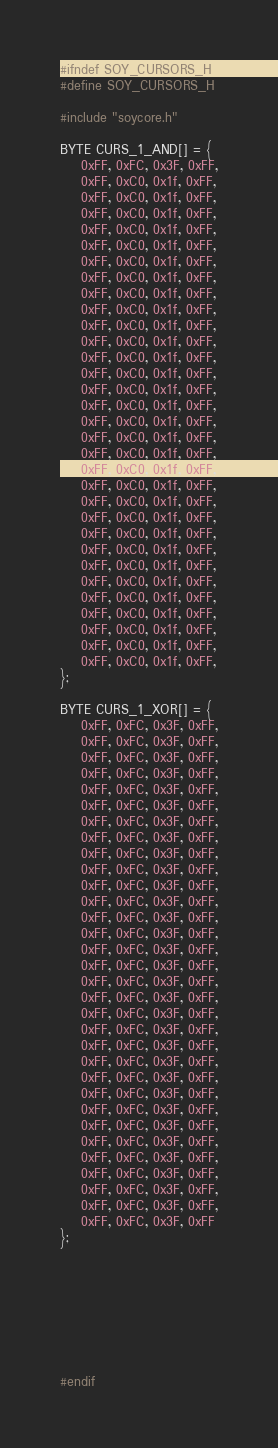<code> <loc_0><loc_0><loc_500><loc_500><_C_>#ifndef SOY_CURSORS_H
#define SOY_CURSORS_H

#include "soycore.h"

BYTE CURS_1_AND[] = {
	0xFF, 0xFC, 0x3F, 0xFF,
	0xFF, 0xC0, 0x1f, 0xFF,
	0xFF, 0xC0, 0x1f, 0xFF,
	0xFF, 0xC0, 0x1f, 0xFF,
	0xFF, 0xC0, 0x1f, 0xFF,
	0xFF, 0xC0, 0x1f, 0xFF,
	0xFF, 0xC0, 0x1f, 0xFF,
	0xFF, 0xC0, 0x1f, 0xFF,
	0xFF, 0xC0, 0x1f, 0xFF,
	0xFF, 0xC0, 0x1f, 0xFF,
	0xFF, 0xC0, 0x1f, 0xFF,
	0xFF, 0xC0, 0x1f, 0xFF,
	0xFF, 0xC0, 0x1f, 0xFF,
	0xFF, 0xC0, 0x1f, 0xFF,
	0xFF, 0xC0, 0x1f, 0xFF,
	0xFF, 0xC0, 0x1f, 0xFF,
	0xFF, 0xC0, 0x1f, 0xFF,
	0xFF, 0xC0, 0x1f, 0xFF,
	0xFF, 0xC0, 0x1f, 0xFF,
	0xFF, 0xC0, 0x1f, 0xFF,
	0xFF, 0xC0, 0x1f, 0xFF,
	0xFF, 0xC0, 0x1f, 0xFF,
	0xFF, 0xC0, 0x1f, 0xFF,
	0xFF, 0xC0, 0x1f, 0xFF,
	0xFF, 0xC0, 0x1f, 0xFF,
	0xFF, 0xC0, 0x1f, 0xFF,
	0xFF, 0xC0, 0x1f, 0xFF,
	0xFF, 0xC0, 0x1f, 0xFF,
	0xFF, 0xC0, 0x1f, 0xFF,
	0xFF, 0xC0, 0x1f, 0xFF,
	0xFF, 0xC0, 0x1f, 0xFF,
	0xFF, 0xC0, 0x1f, 0xFF,
};

BYTE CURS_1_XOR[] = {
	0xFF, 0xFC, 0x3F, 0xFF,
	0xFF, 0xFC, 0x3F, 0xFF,
	0xFF, 0xFC, 0x3F, 0xFF,
	0xFF, 0xFC, 0x3F, 0xFF,
	0xFF, 0xFC, 0x3F, 0xFF,
	0xFF, 0xFC, 0x3F, 0xFF,
	0xFF, 0xFC, 0x3F, 0xFF,
	0xFF, 0xFC, 0x3F, 0xFF,
	0xFF, 0xFC, 0x3F, 0xFF,
	0xFF, 0xFC, 0x3F, 0xFF,
	0xFF, 0xFC, 0x3F, 0xFF,
	0xFF, 0xFC, 0x3F, 0xFF,
	0xFF, 0xFC, 0x3F, 0xFF,
	0xFF, 0xFC, 0x3F, 0xFF,
	0xFF, 0xFC, 0x3F, 0xFF,
	0xFF, 0xFC, 0x3F, 0xFF,
	0xFF, 0xFC, 0x3F, 0xFF,
	0xFF, 0xFC, 0x3F, 0xFF,
	0xFF, 0xFC, 0x3F, 0xFF,
	0xFF, 0xFC, 0x3F, 0xFF,
	0xFF, 0xFC, 0x3F, 0xFF,
	0xFF, 0xFC, 0x3F, 0xFF,
	0xFF, 0xFC, 0x3F, 0xFF,
	0xFF, 0xFC, 0x3F, 0xFF,
	0xFF, 0xFC, 0x3F, 0xFF,
	0xFF, 0xFC, 0x3F, 0xFF,
	0xFF, 0xFC, 0x3F, 0xFF,
	0xFF, 0xFC, 0x3F, 0xFF,
	0xFF, 0xFC, 0x3F, 0xFF,
	0xFF, 0xFC, 0x3F, 0xFF,
	0xFF, 0xFC, 0x3F, 0xFF,
	0xFF, 0xFC, 0x3F, 0xFF
};








#endif
</code> 